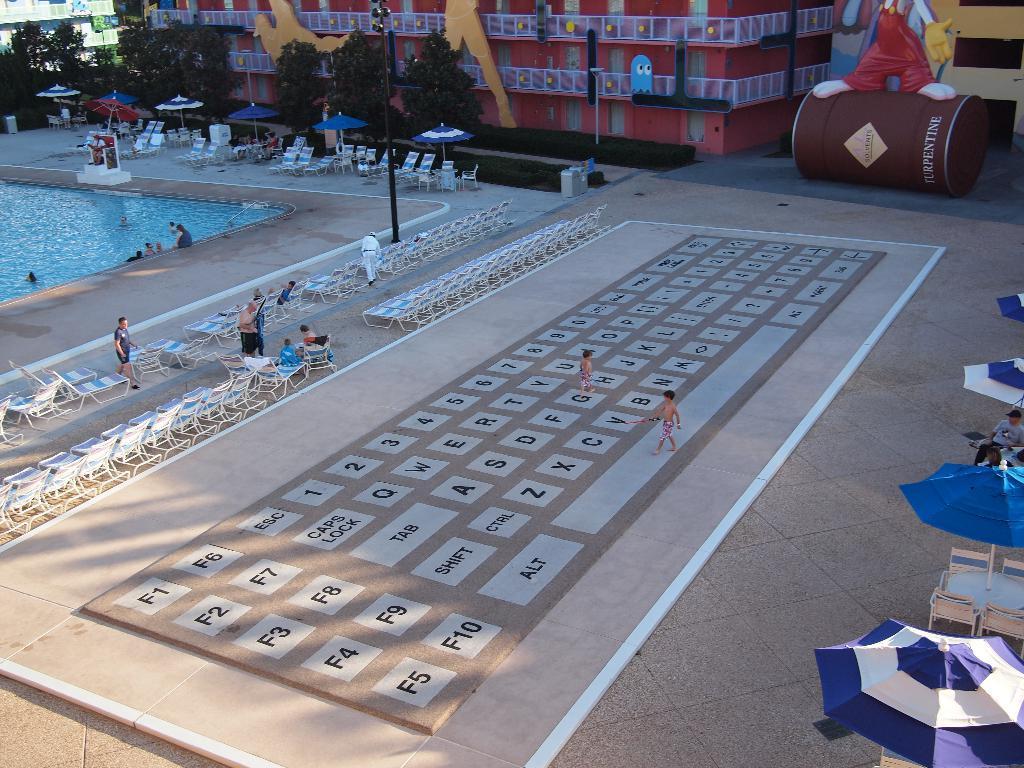Could you give a brief overview of what you see in this image? In this image there is a floor in the middle on which there is a keyboard painting. Beside it there are chairs which are kept side by side. On the left side there is a pool in which there are few people swimming in it. In the background there is a building. In front of the building there are trees. On the right side there are umbrellas under which there are chairs. At the top there is a statue on the drum. 